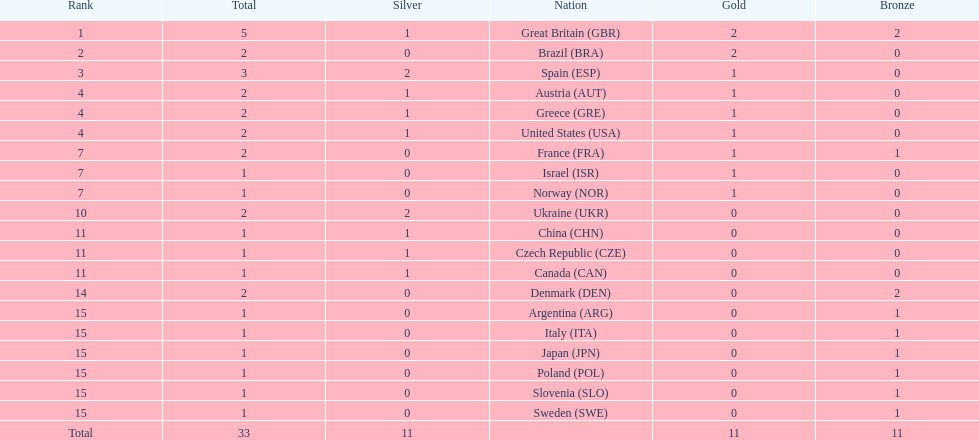How many gold medals did italy receive? 0. 